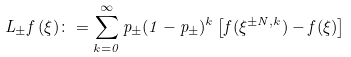Convert formula to latex. <formula><loc_0><loc_0><loc_500><loc_500>L _ { \pm } f \, ( \xi ) \colon = \sum _ { k = 0 } ^ { \infty } p _ { \pm } ( 1 - p _ { \pm } ) ^ { k } \left [ f ( \xi ^ { \pm N , k } ) - f ( \xi ) \right ]</formula> 